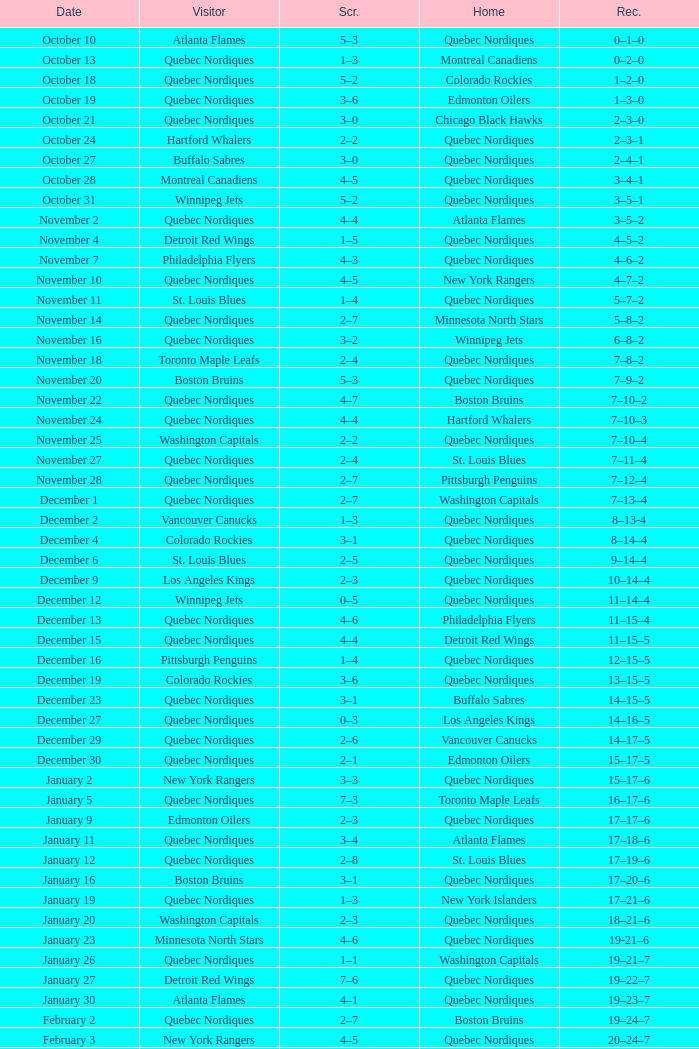Which Record has a Score of 2–4, and a Home of quebec nordiques? 7–8–2. 